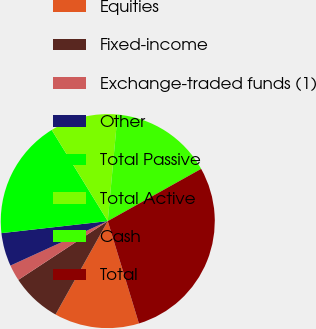Convert chart to OTSL. <chart><loc_0><loc_0><loc_500><loc_500><pie_chart><fcel>Equities<fcel>Fixed-income<fcel>Exchange-traded funds (1)<fcel>Other<fcel>Total Passive<fcel>Total Active<fcel>Cash<fcel>Total<nl><fcel>12.82%<fcel>7.63%<fcel>2.43%<fcel>5.03%<fcel>18.02%<fcel>10.23%<fcel>15.42%<fcel>28.41%<nl></chart> 